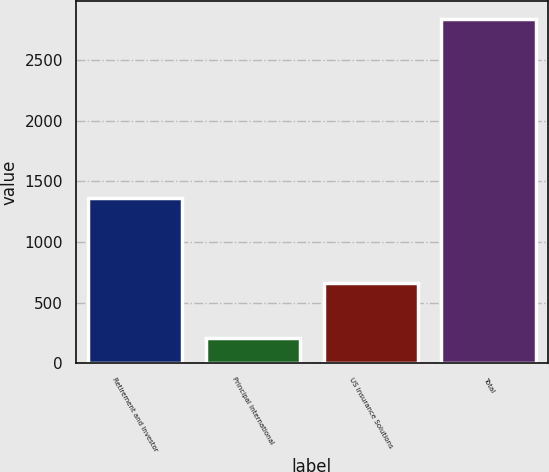Convert chart. <chart><loc_0><loc_0><loc_500><loc_500><bar_chart><fcel>Retirement and Investor<fcel>Principal International<fcel>US Insurance Solutions<fcel>Total<nl><fcel>1362.5<fcel>211.4<fcel>662<fcel>2841.5<nl></chart> 